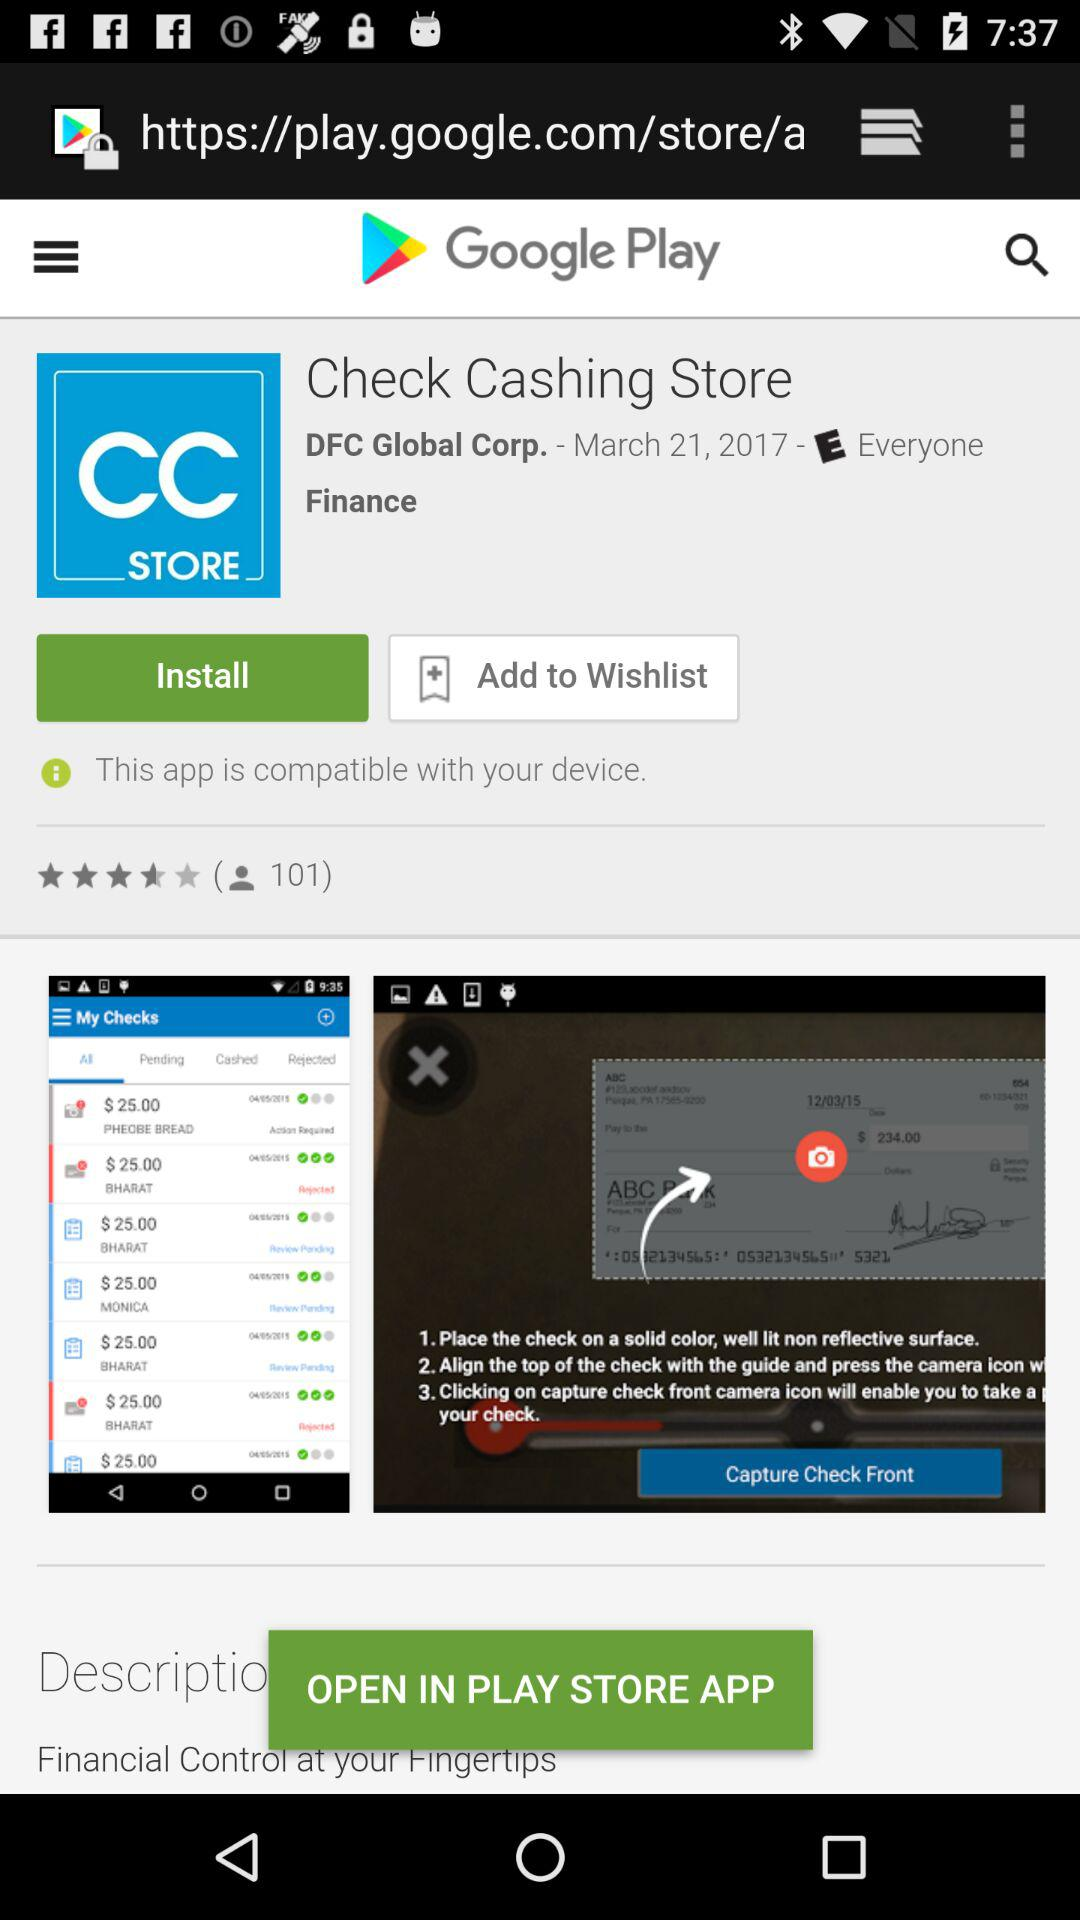How many people have rated this application? This application has been rated by 101 people. 